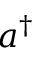Convert formula to latex. <formula><loc_0><loc_0><loc_500><loc_500>a ^ { \dagger }</formula> 